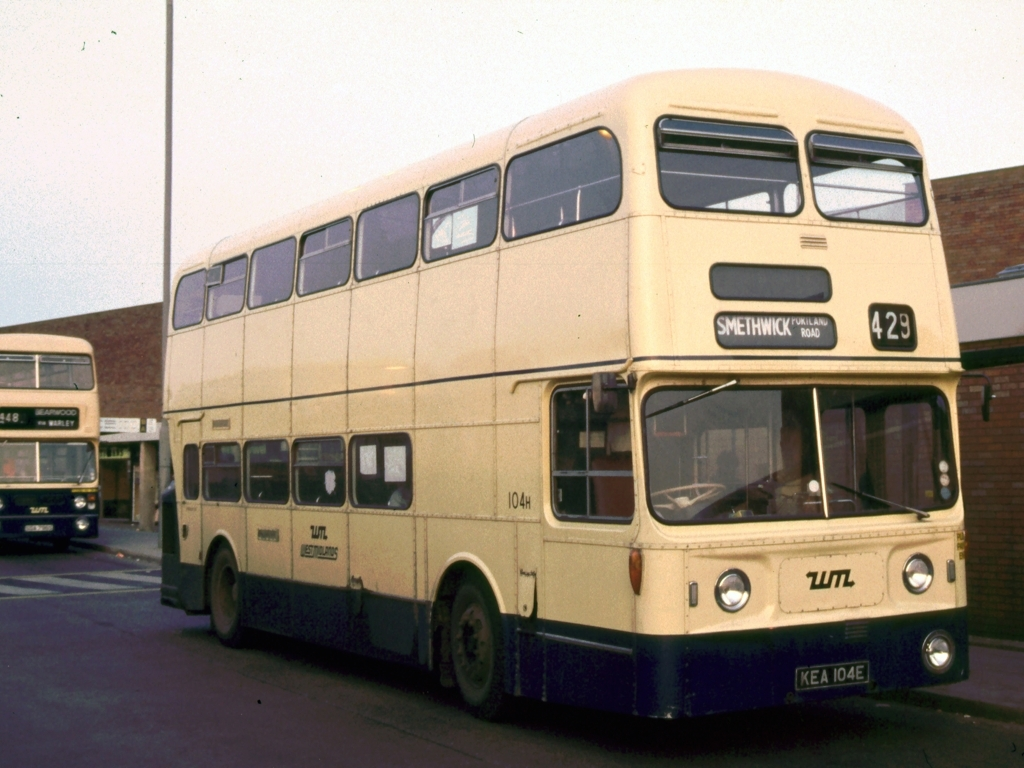Could you elaborate on the livery design on the bus? Certainly, the bus features a two-tone livery that was common for public transport vehicles at the time. The lower part is a darker color to help disguise dirt and road grime, while the upper part is lighter to be more visible to potential passengers. This particular color scheme would have been chosen by the bus company, often to align with their branding or regional colors. 